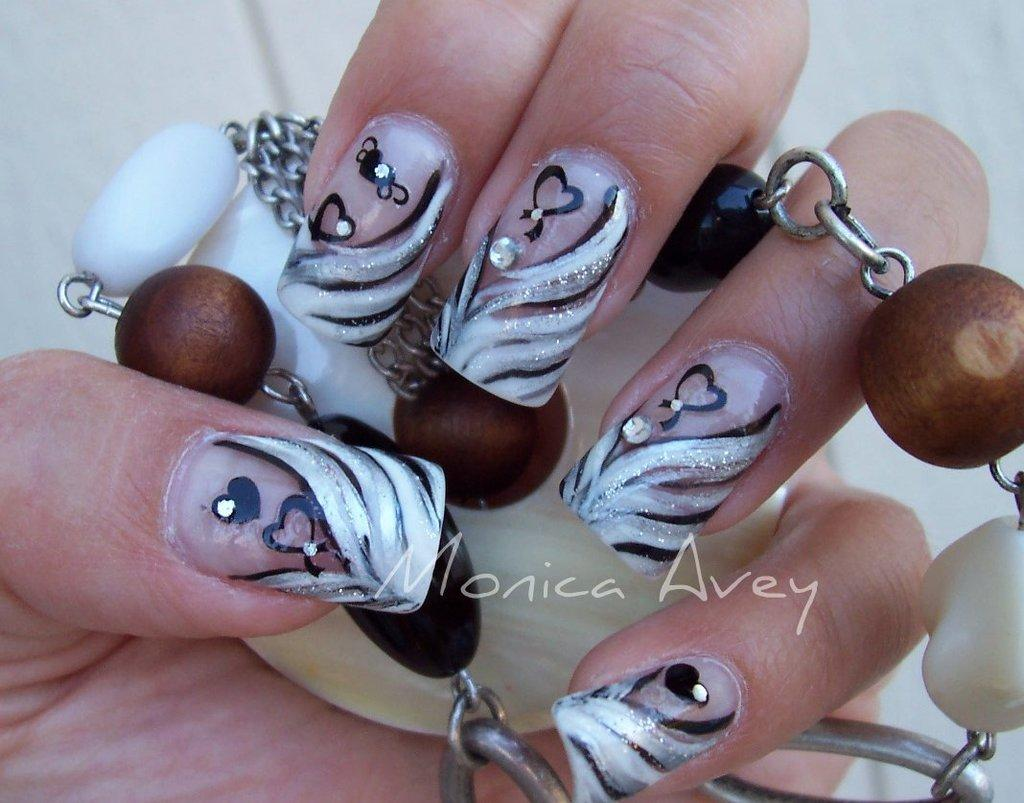What is the person's hand holding in the image? The person's hand is holding a chain in the image. What can be seen on the person's nails in the image? There is nail art visible in the image. What type of coast can be seen in the background of the image? There is no coast visible in the image; it only shows a person's hand holding a chain and nail art. What type of ring is the person wearing on their finger in the image? There is no ring visible on the person's finger in the image. 